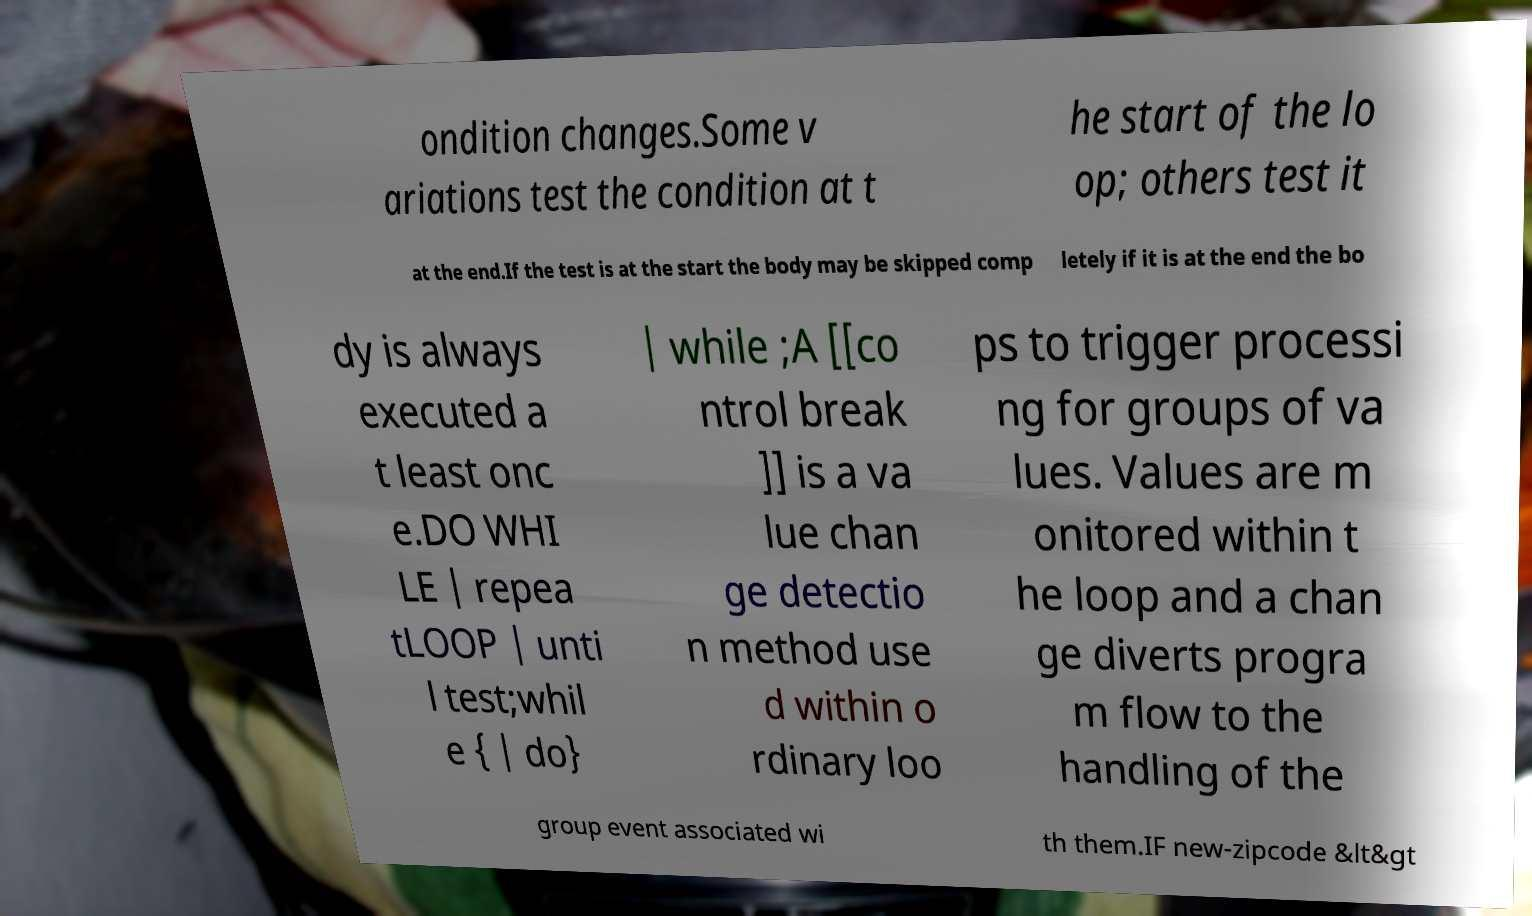Can you read and provide the text displayed in the image?This photo seems to have some interesting text. Can you extract and type it out for me? ondition changes.Some v ariations test the condition at t he start of the lo op; others test it at the end.If the test is at the start the body may be skipped comp letely if it is at the end the bo dy is always executed a t least onc e.DO WHI LE | repea tLOOP | unti l test;whil e { | do} | while ;A [[co ntrol break ]] is a va lue chan ge detectio n method use d within o rdinary loo ps to trigger processi ng for groups of va lues. Values are m onitored within t he loop and a chan ge diverts progra m flow to the handling of the group event associated wi th them.IF new-zipcode &lt&gt 